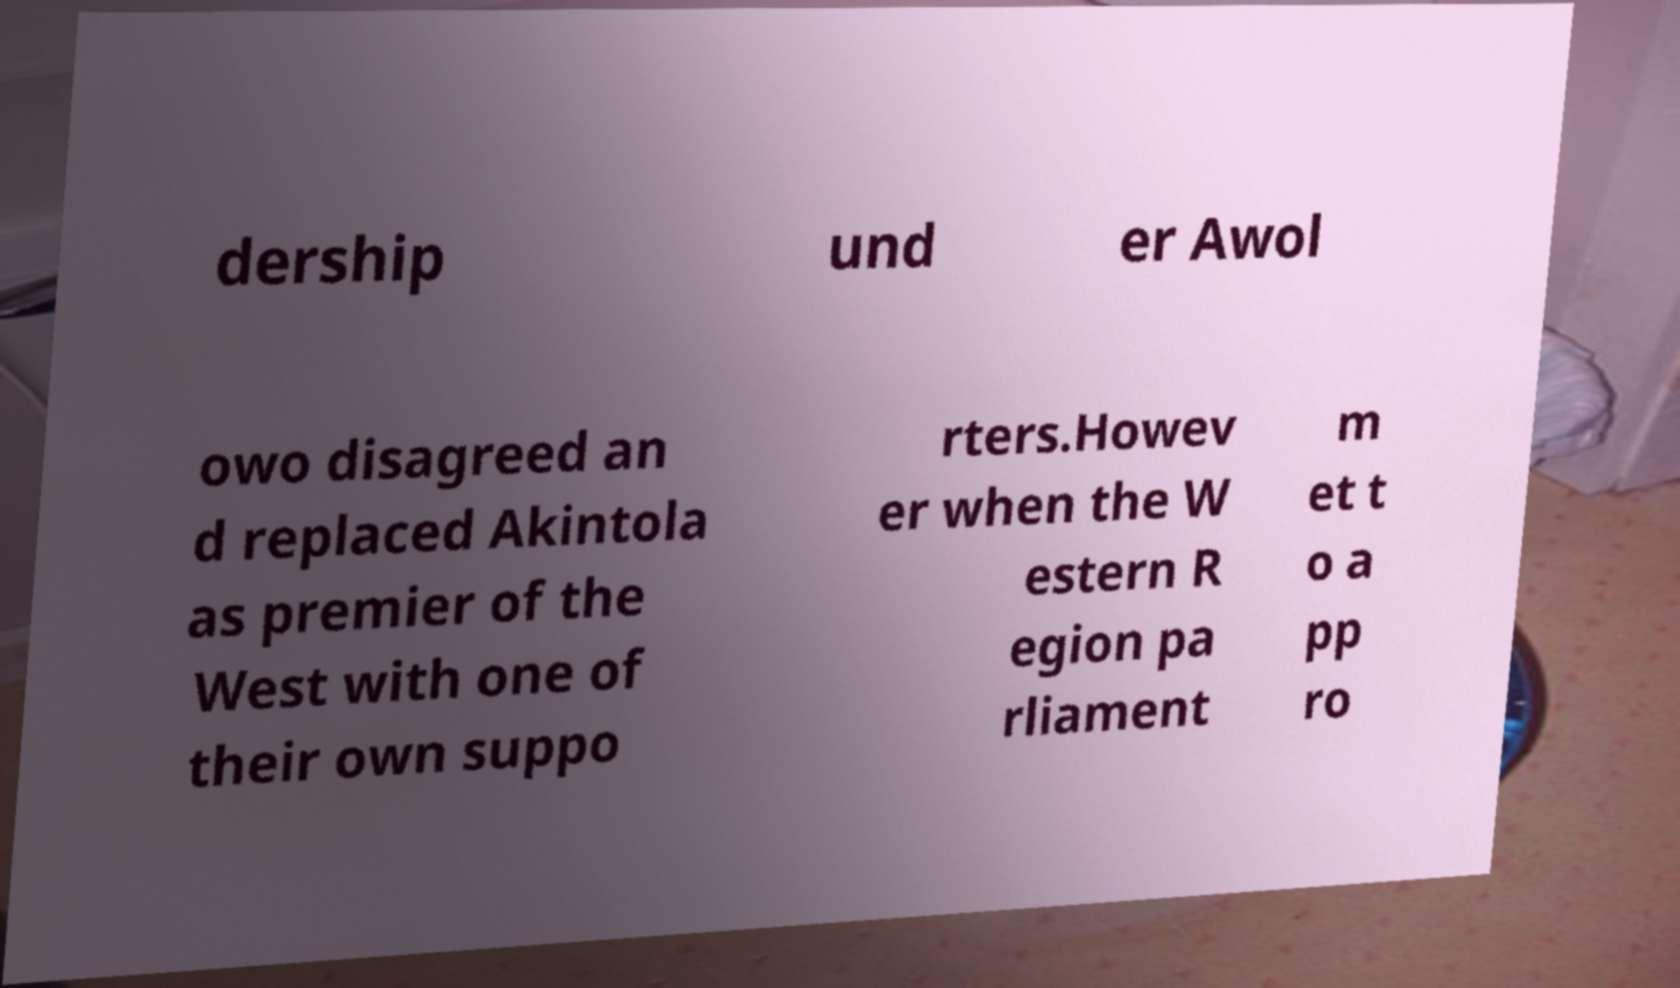What messages or text are displayed in this image? I need them in a readable, typed format. dership und er Awol owo disagreed an d replaced Akintola as premier of the West with one of their own suppo rters.Howev er when the W estern R egion pa rliament m et t o a pp ro 